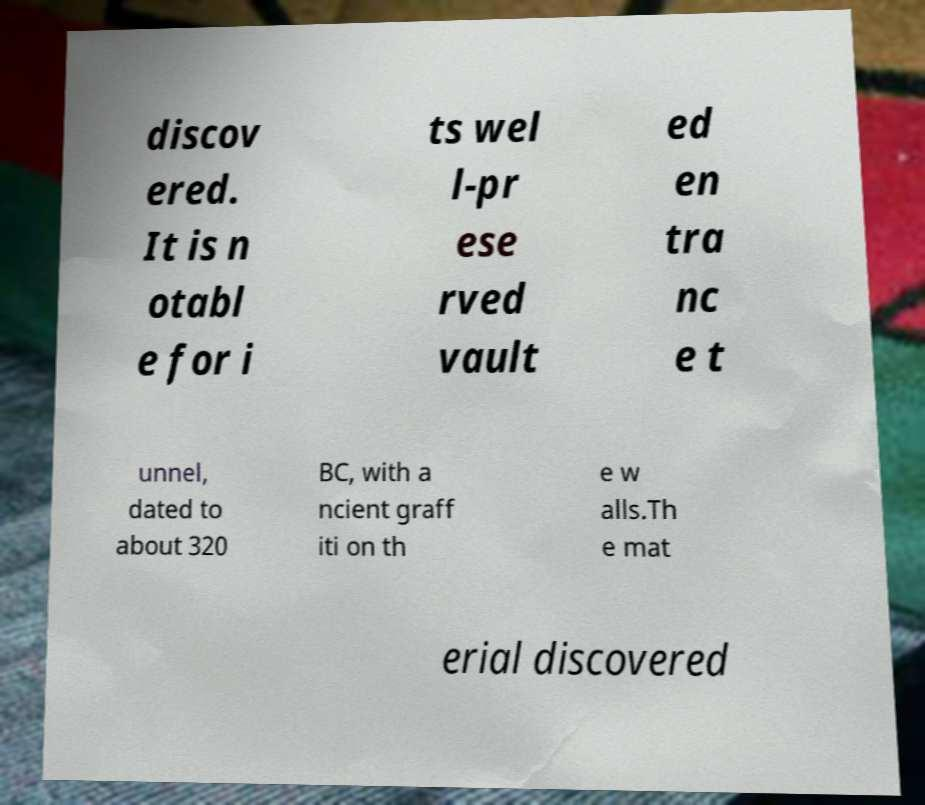Could you extract and type out the text from this image? discov ered. It is n otabl e for i ts wel l-pr ese rved vault ed en tra nc e t unnel, dated to about 320 BC, with a ncient graff iti on th e w alls.Th e mat erial discovered 